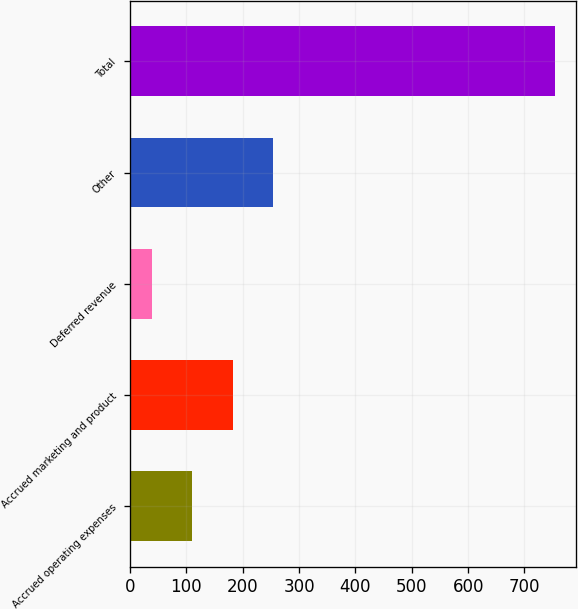Convert chart to OTSL. <chart><loc_0><loc_0><loc_500><loc_500><bar_chart><fcel>Accrued operating expenses<fcel>Accrued marketing and product<fcel>Deferred revenue<fcel>Other<fcel>Total<nl><fcel>110.5<fcel>182<fcel>39<fcel>253.5<fcel>754<nl></chart> 